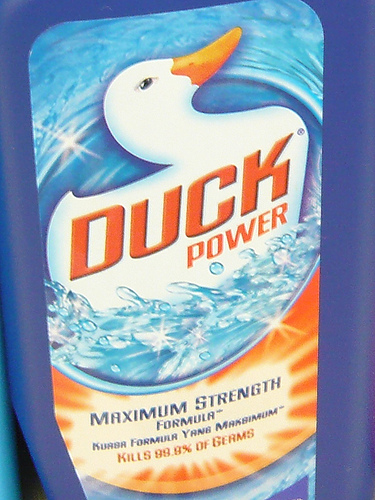<image>
Is there a duck on the cleaner? Yes. Looking at the image, I can see the duck is positioned on top of the cleaner, with the cleaner providing support. 